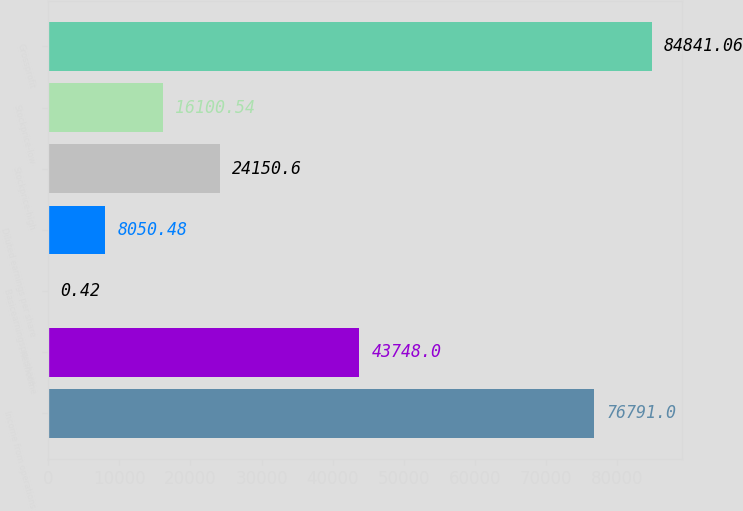<chart> <loc_0><loc_0><loc_500><loc_500><bar_chart><fcel>Income from operations<fcel>Netincome<fcel>Basicearningsper share<fcel>Diluted earnings per share<fcel>Stockprice-high<fcel>Stockprice-low<fcel>Grossprofit<nl><fcel>76791<fcel>43748<fcel>0.42<fcel>8050.48<fcel>24150.6<fcel>16100.5<fcel>84841.1<nl></chart> 